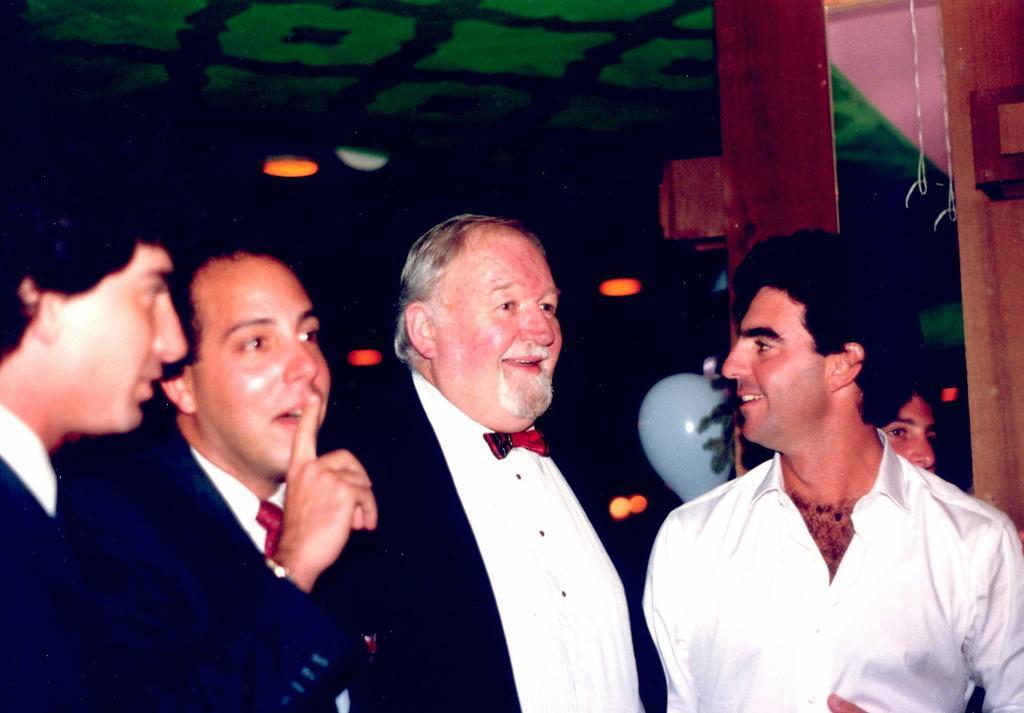How would you summarize this image in a sentence or two? This picture shows the inner view of a room with green ceiling, so many lights, some objects are on the surface, some threads and some people are standing. 